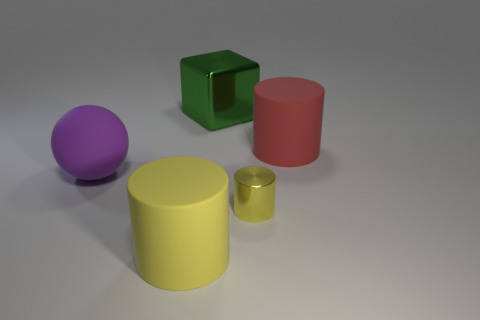Are there any other things that have the same size as the yellow metal thing?
Offer a very short reply. No. Is there any other thing that has the same shape as the green shiny thing?
Make the answer very short. No. How big is the yellow metallic cylinder that is right of the large green metal block?
Provide a short and direct response. Small. Does the big red rubber thing have the same shape as the tiny yellow metallic thing?
Make the answer very short. Yes. How many tiny objects are red matte objects or yellow metal spheres?
Offer a very short reply. 0. Are there any tiny yellow cylinders in front of the large yellow matte cylinder?
Provide a succinct answer. No. Are there the same number of large green blocks in front of the tiny shiny thing and large purple balls?
Provide a succinct answer. No. The metal object that is the same shape as the large yellow matte thing is what size?
Provide a succinct answer. Small. There is a small metallic thing; does it have the same shape as the yellow matte thing in front of the big block?
Make the answer very short. Yes. There is a matte thing that is on the right side of the tiny cylinder right of the big purple matte ball; what is its size?
Make the answer very short. Large. 